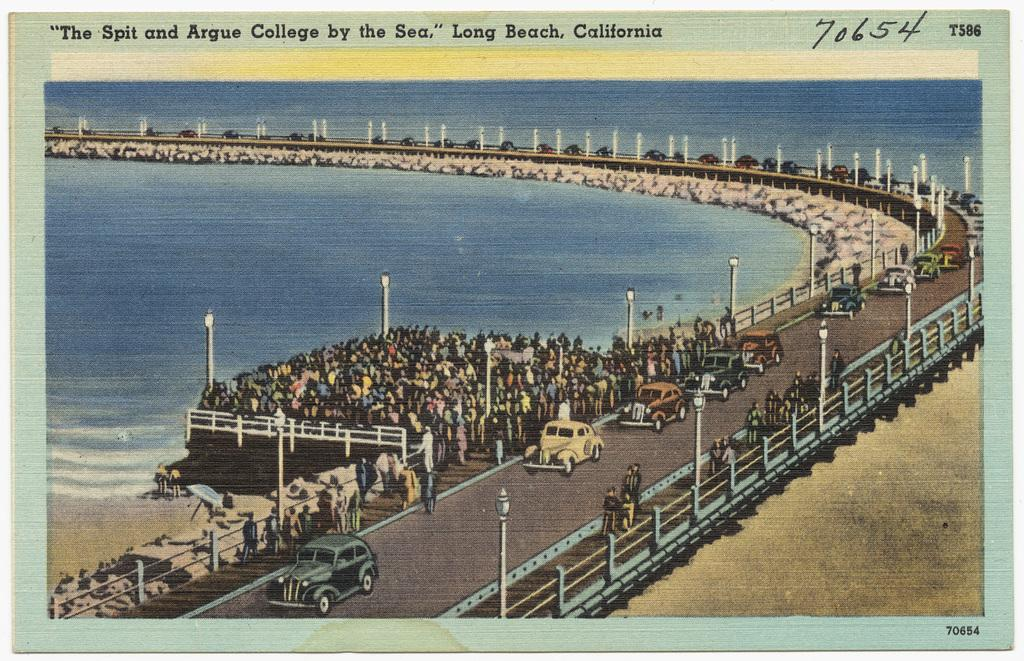What type of publication does the image come from? The image is from a magazine. Can you describe the scene in the image? There is a group of people, cars, electric light poles, a road, a bridge, and water visible in the image. What might be used to illuminate the area at night? Electric light poles are present in the image, which might be used to illuminate the area at night. Is there any text in the image? Yes, there is text at the top of the image. What type of pot is being used for breakfast in the image? There is no pot or breakfast present in the image; it features a group of people, cars, electric light poles, a road, a bridge, and water. What type of coil is visible in the image? There is no coil present in the image. 